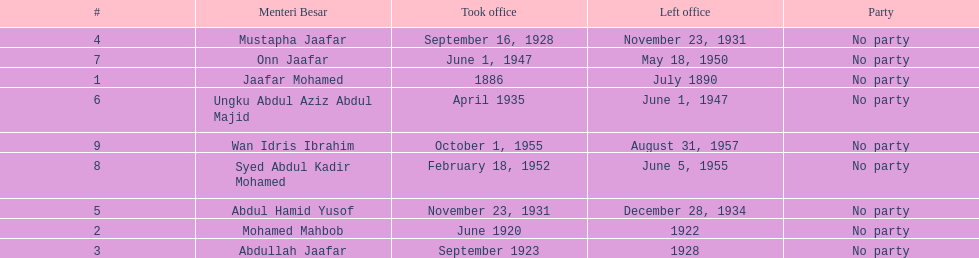How many years was jaafar mohamed in office? 4. 